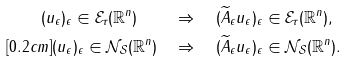Convert formula to latex. <formula><loc_0><loc_0><loc_500><loc_500>( u _ { \epsilon } ) _ { \epsilon } \in \mathcal { E } _ { \tau } ( \mathbb { R } ^ { n } ) \quad & \Rightarrow \quad ( { \widetilde { A } } _ { \epsilon } u _ { \epsilon } ) _ { \epsilon } \in \mathcal { E } _ { \tau } ( \mathbb { R } ^ { n } ) , \\ [ 0 . 2 c m ] ( u _ { \epsilon } ) _ { \epsilon } \in \mathcal { N } _ { \mathcal { S } } ( \mathbb { R } ^ { n } ) \quad & \Rightarrow \quad ( { \widetilde { A } } _ { \epsilon } u _ { \epsilon } ) _ { \epsilon } \in \mathcal { N } _ { \mathcal { S } } ( \mathbb { R } ^ { n } ) .</formula> 